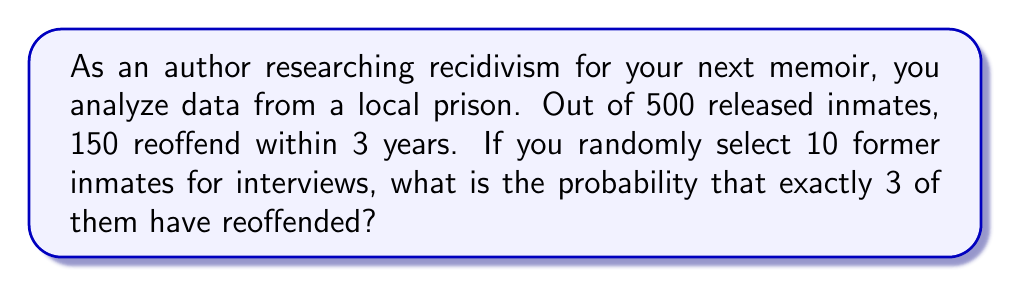Show me your answer to this math problem. Let's approach this step-by-step using the binomial probability distribution:

1) First, we need to calculate the probability of reoffending:
   $p = \frac{150}{500} = 0.3$ or 30%

2) The probability of not reoffending is:
   $q = 1 - p = 1 - 0.3 = 0.7$ or 70%

3) We want exactly 3 out of 10 to have reoffended. This follows a binomial distribution with parameters:
   $n = 10$ (number of trials)
   $k = 3$ (number of successes)
   $p = 0.3$ (probability of success on each trial)

4) The binomial probability formula is:

   $$P(X = k) = \binom{n}{k} p^k (1-p)^{n-k}$$

5) Plugging in our values:

   $$P(X = 3) = \binom{10}{3} (0.3)^3 (0.7)^7$$

6) Calculate the binomial coefficient:
   
   $$\binom{10}{3} = \frac{10!}{3!(10-3)!} = \frac{10!}{3!7!} = 120$$

7) Now we can compute:

   $$P(X = 3) = 120 \cdot (0.3)^3 \cdot (0.7)^7$$
   
   $$= 120 \cdot 0.027 \cdot 0.0824$$
   
   $$= 0.2668$$

8) Therefore, the probability is approximately 0.2668 or 26.68%
Answer: 0.2668 